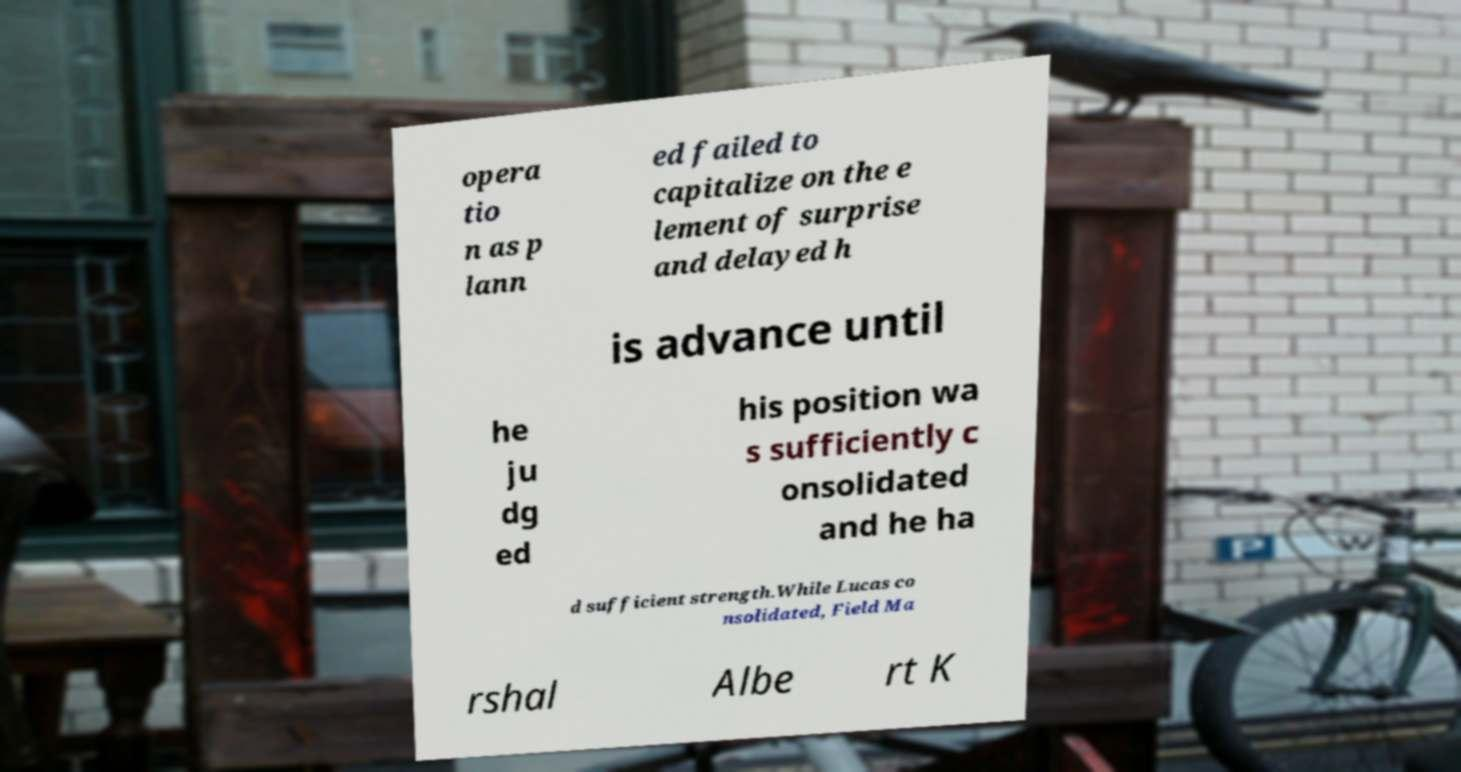Can you read and provide the text displayed in the image?This photo seems to have some interesting text. Can you extract and type it out for me? opera tio n as p lann ed failed to capitalize on the e lement of surprise and delayed h is advance until he ju dg ed his position wa s sufficiently c onsolidated and he ha d sufficient strength.While Lucas co nsolidated, Field Ma rshal Albe rt K 